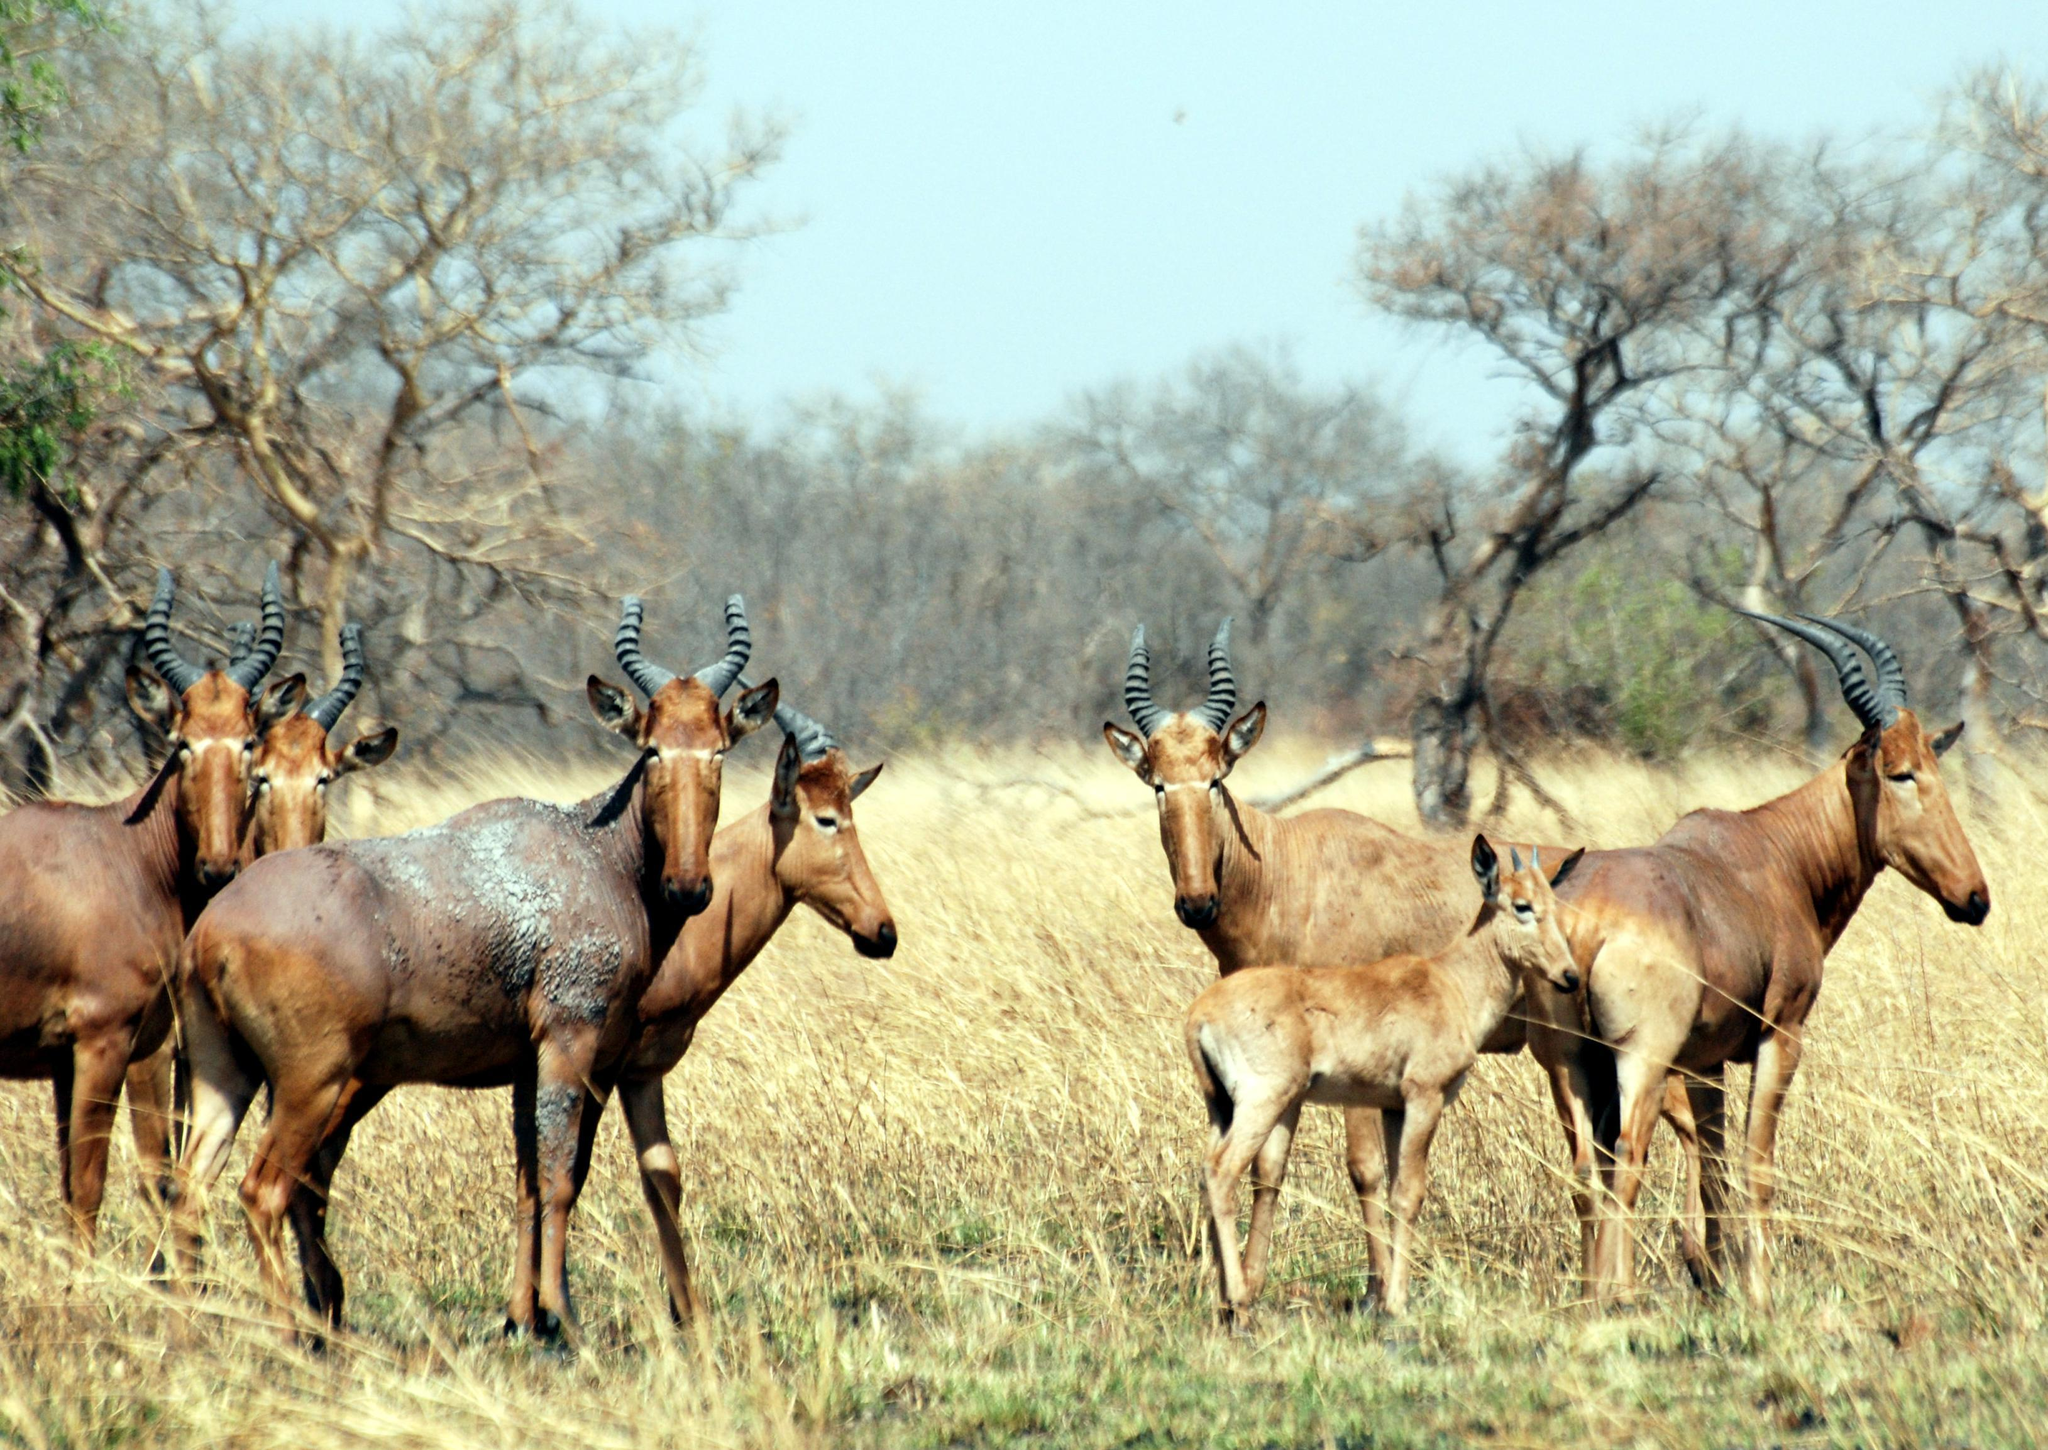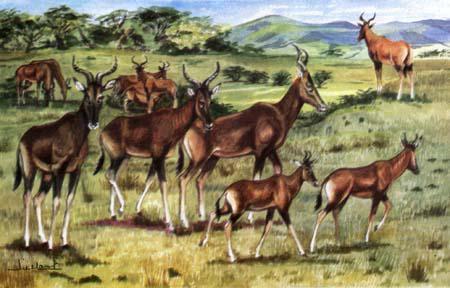The first image is the image on the left, the second image is the image on the right. Considering the images on both sides, is "there are no more than three animals in the image on the right" valid? Answer yes or no. No. 